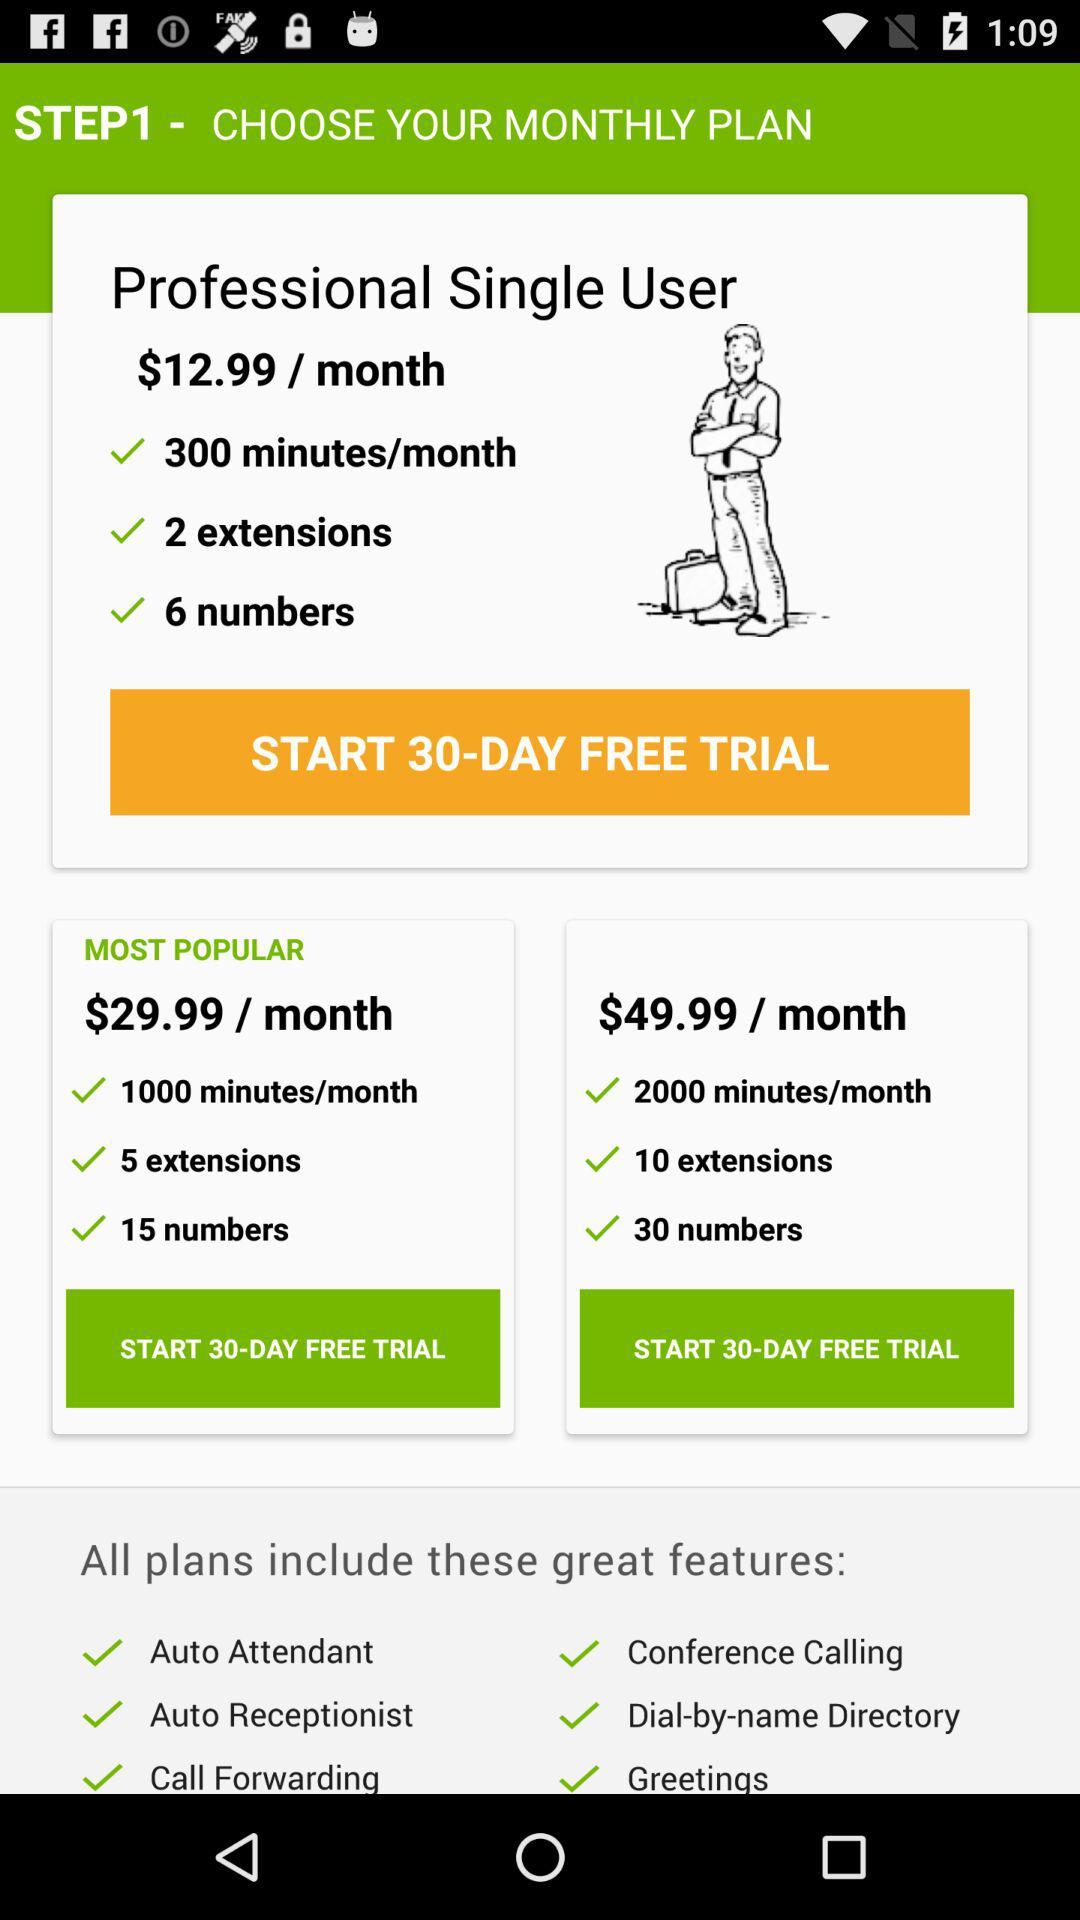What is the price of the most popular plan? The price of the most popular plan is $29.99 per month. 